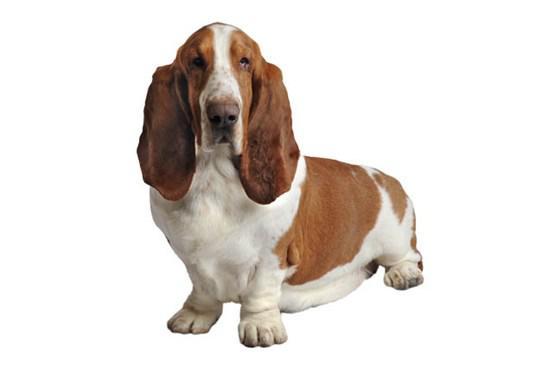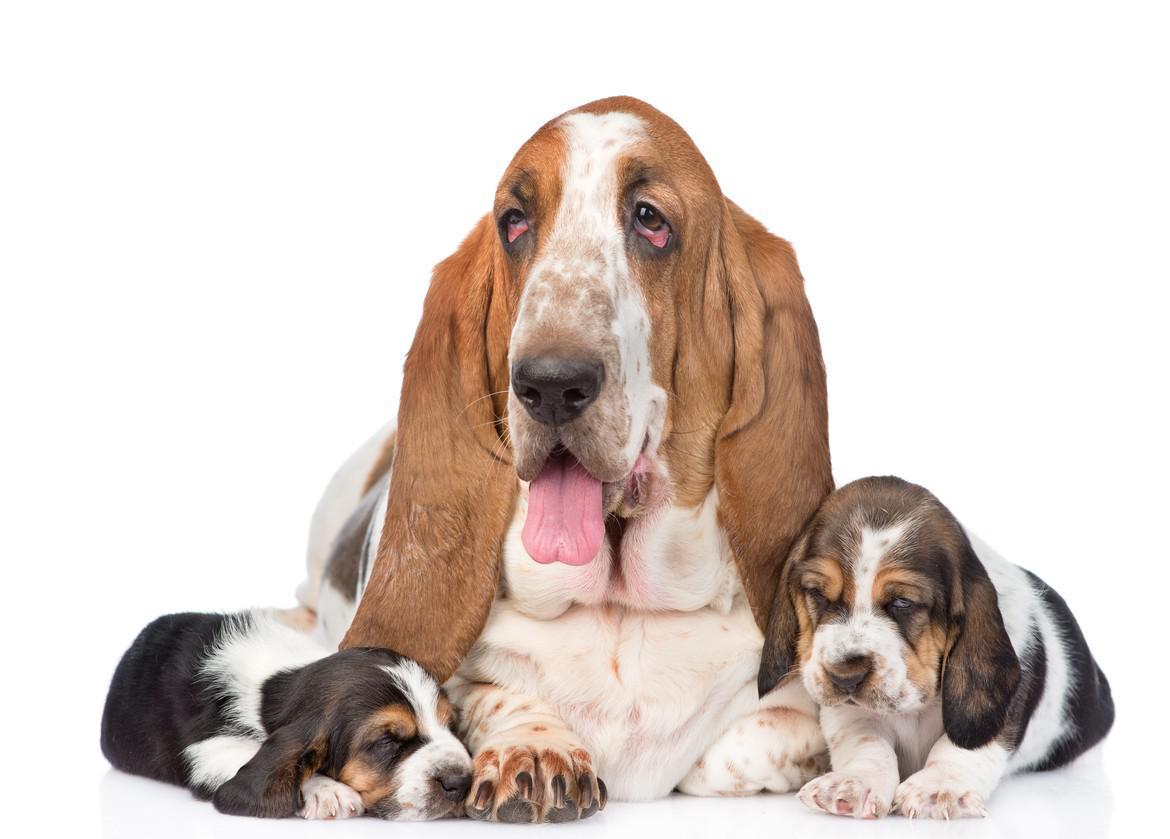The first image is the image on the left, the second image is the image on the right. Given the left and right images, does the statement "There are at least two dogs in the image on the right." hold true? Answer yes or no. Yes. 